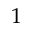<formula> <loc_0><loc_0><loc_500><loc_500>1</formula> 